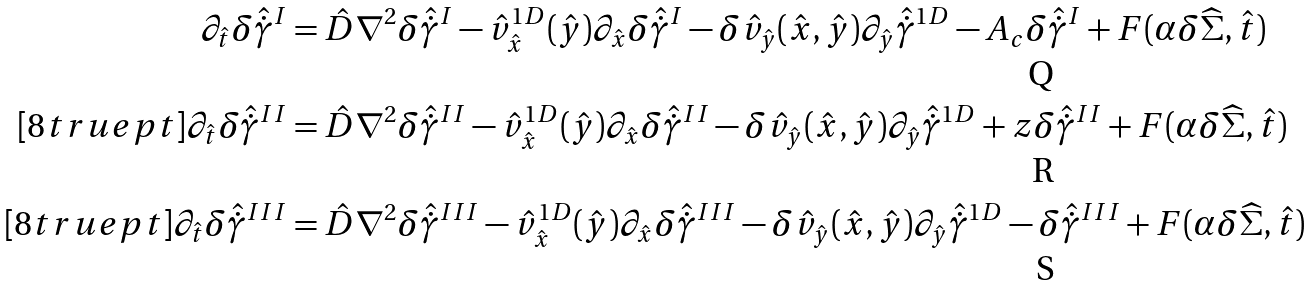<formula> <loc_0><loc_0><loc_500><loc_500>\partial _ { \hat { t } } \delta \hat { \dot { \gamma } } ^ { I } & = \hat { D } \nabla ^ { 2 } \delta \hat { \dot { \gamma } } ^ { I } - \hat { v } _ { \hat { x } } ^ { 1 D } ( \hat { y } ) \partial _ { \hat { x } } \delta \hat { \dot { \gamma } } ^ { I } - \delta \hat { v } _ { \hat { y } } ( \hat { x } , \hat { y } ) \partial _ { \hat { y } } \hat { \dot { \gamma } } ^ { 1 D } - A _ { c } \delta \hat { \dot { \gamma } } ^ { I } + F ( \alpha \delta \widehat { \Sigma } , \hat { t } ) \\ [ 8 t r u e p t ] \partial _ { \hat { t } } \delta \hat { \dot { \gamma } } ^ { I I } & = \hat { D } \nabla ^ { 2 } \delta \hat { \dot { \gamma } } ^ { I I } - \hat { v } _ { \hat { x } } ^ { 1 D } ( \hat { y } ) \partial _ { \hat { x } } \delta \hat { \dot { \gamma } } ^ { I I } - \delta \hat { v } _ { \hat { y } } ( \hat { x } , \hat { y } ) \partial _ { \hat { y } } \hat { \dot { \gamma } } ^ { 1 D } + z \delta \hat { \dot { \gamma } } ^ { I I } + F ( \alpha \delta \widehat { \Sigma } , \hat { t } ) \\ [ 8 t r u e p t ] \partial _ { \hat { t } } \delta \hat { \dot { \gamma } } ^ { I I I } & = \hat { D } \nabla ^ { 2 } \delta \hat { \dot { \gamma } } ^ { I I I } - \hat { v } _ { \hat { x } } ^ { 1 D } ( \hat { y } ) \partial _ { \hat { x } } \delta \hat { \dot { \gamma } } ^ { I I I } - \delta \hat { v } _ { \hat { y } } ( \hat { x } , \hat { y } ) \partial _ { \hat { y } } \hat { \dot { \gamma } } ^ { 1 D } - \delta \hat { \dot { \gamma } } ^ { I I I } + F ( \alpha \delta \widehat { \Sigma } , \hat { t } )</formula> 